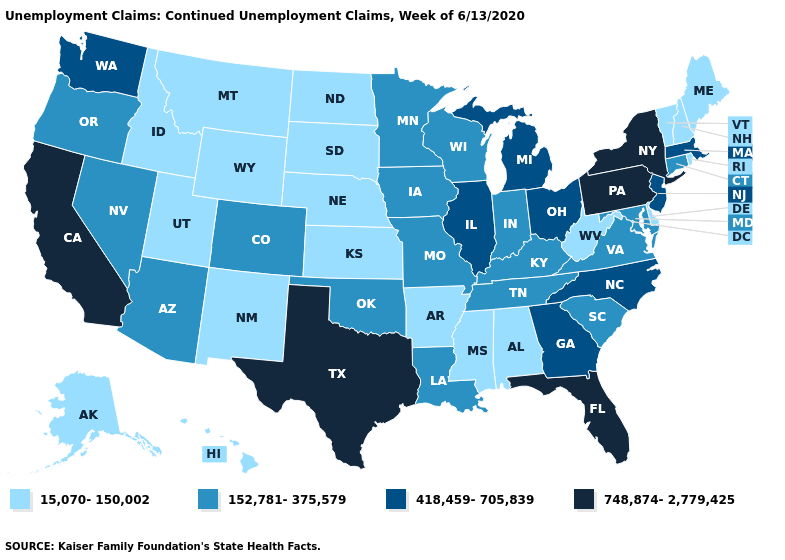What is the lowest value in states that border Mississippi?
Keep it brief. 15,070-150,002. Name the states that have a value in the range 15,070-150,002?
Be succinct. Alabama, Alaska, Arkansas, Delaware, Hawaii, Idaho, Kansas, Maine, Mississippi, Montana, Nebraska, New Hampshire, New Mexico, North Dakota, Rhode Island, South Dakota, Utah, Vermont, West Virginia, Wyoming. What is the highest value in the USA?
Concise answer only. 748,874-2,779,425. What is the highest value in the USA?
Be succinct. 748,874-2,779,425. Does Hawaii have the lowest value in the USA?
Write a very short answer. Yes. Name the states that have a value in the range 418,459-705,839?
Be succinct. Georgia, Illinois, Massachusetts, Michigan, New Jersey, North Carolina, Ohio, Washington. What is the lowest value in states that border Michigan?
Quick response, please. 152,781-375,579. Name the states that have a value in the range 418,459-705,839?
Short answer required. Georgia, Illinois, Massachusetts, Michigan, New Jersey, North Carolina, Ohio, Washington. What is the value of Tennessee?
Write a very short answer. 152,781-375,579. Does Nebraska have the lowest value in the USA?
Answer briefly. Yes. What is the lowest value in the USA?
Be succinct. 15,070-150,002. Does the first symbol in the legend represent the smallest category?
Answer briefly. Yes. Does Pennsylvania have the highest value in the USA?
Answer briefly. Yes. Does Colorado have the lowest value in the USA?
Concise answer only. No. Among the states that border North Dakota , which have the lowest value?
Concise answer only. Montana, South Dakota. 